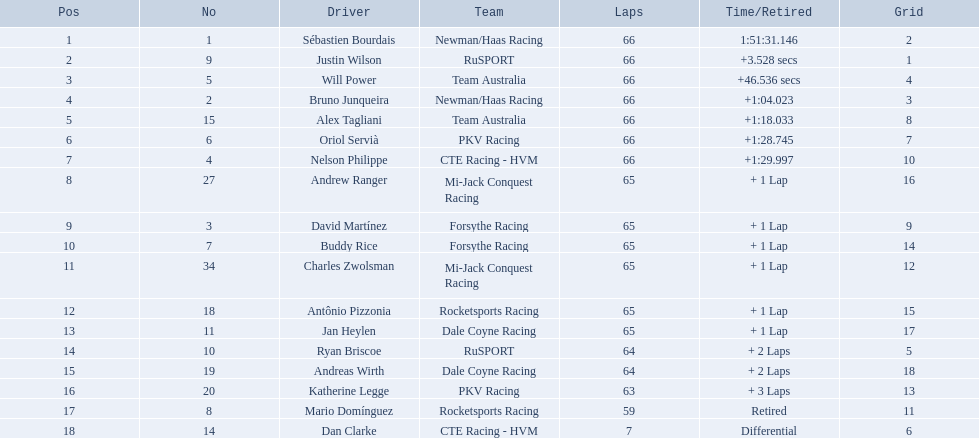What are the drivers numbers? 1, 9, 5, 2, 15, 6, 4, 27, 3, 7, 34, 18, 11, 10, 19, 20, 8, 14. Are there any who's number matches his position? Sébastien Bourdais, Oriol Servià. Of those two who has the highest position? Sébastien Bourdais. Parse the table in full. {'header': ['Pos', 'No', 'Driver', 'Team', 'Laps', 'Time/Retired', 'Grid'], 'rows': [['1', '1', 'Sébastien Bourdais', 'Newman/Haas Racing', '66', '1:51:31.146', '2'], ['2', '9', 'Justin Wilson', 'RuSPORT', '66', '+3.528 secs', '1'], ['3', '5', 'Will Power', 'Team Australia', '66', '+46.536 secs', '4'], ['4', '2', 'Bruno Junqueira', 'Newman/Haas Racing', '66', '+1:04.023', '3'], ['5', '15', 'Alex Tagliani', 'Team Australia', '66', '+1:18.033', '8'], ['6', '6', 'Oriol Servià', 'PKV Racing', '66', '+1:28.745', '7'], ['7', '4', 'Nelson Philippe', 'CTE Racing - HVM', '66', '+1:29.997', '10'], ['8', '27', 'Andrew Ranger', 'Mi-Jack Conquest Racing', '65', '+ 1 Lap', '16'], ['9', '3', 'David Martínez', 'Forsythe Racing', '65', '+ 1 Lap', '9'], ['10', '7', 'Buddy Rice', 'Forsythe Racing', '65', '+ 1 Lap', '14'], ['11', '34', 'Charles Zwolsman', 'Mi-Jack Conquest Racing', '65', '+ 1 Lap', '12'], ['12', '18', 'Antônio Pizzonia', 'Rocketsports Racing', '65', '+ 1 Lap', '15'], ['13', '11', 'Jan Heylen', 'Dale Coyne Racing', '65', '+ 1 Lap', '17'], ['14', '10', 'Ryan Briscoe', 'RuSPORT', '64', '+ 2 Laps', '5'], ['15', '19', 'Andreas Wirth', 'Dale Coyne Racing', '64', '+ 2 Laps', '18'], ['16', '20', 'Katherine Legge', 'PKV Racing', '63', '+ 3 Laps', '13'], ['17', '8', 'Mario Domínguez', 'Rocketsports Racing', '59', 'Retired', '11'], ['18', '14', 'Dan Clarke', 'CTE Racing - HVM', '7', 'Differential', '6']]} 